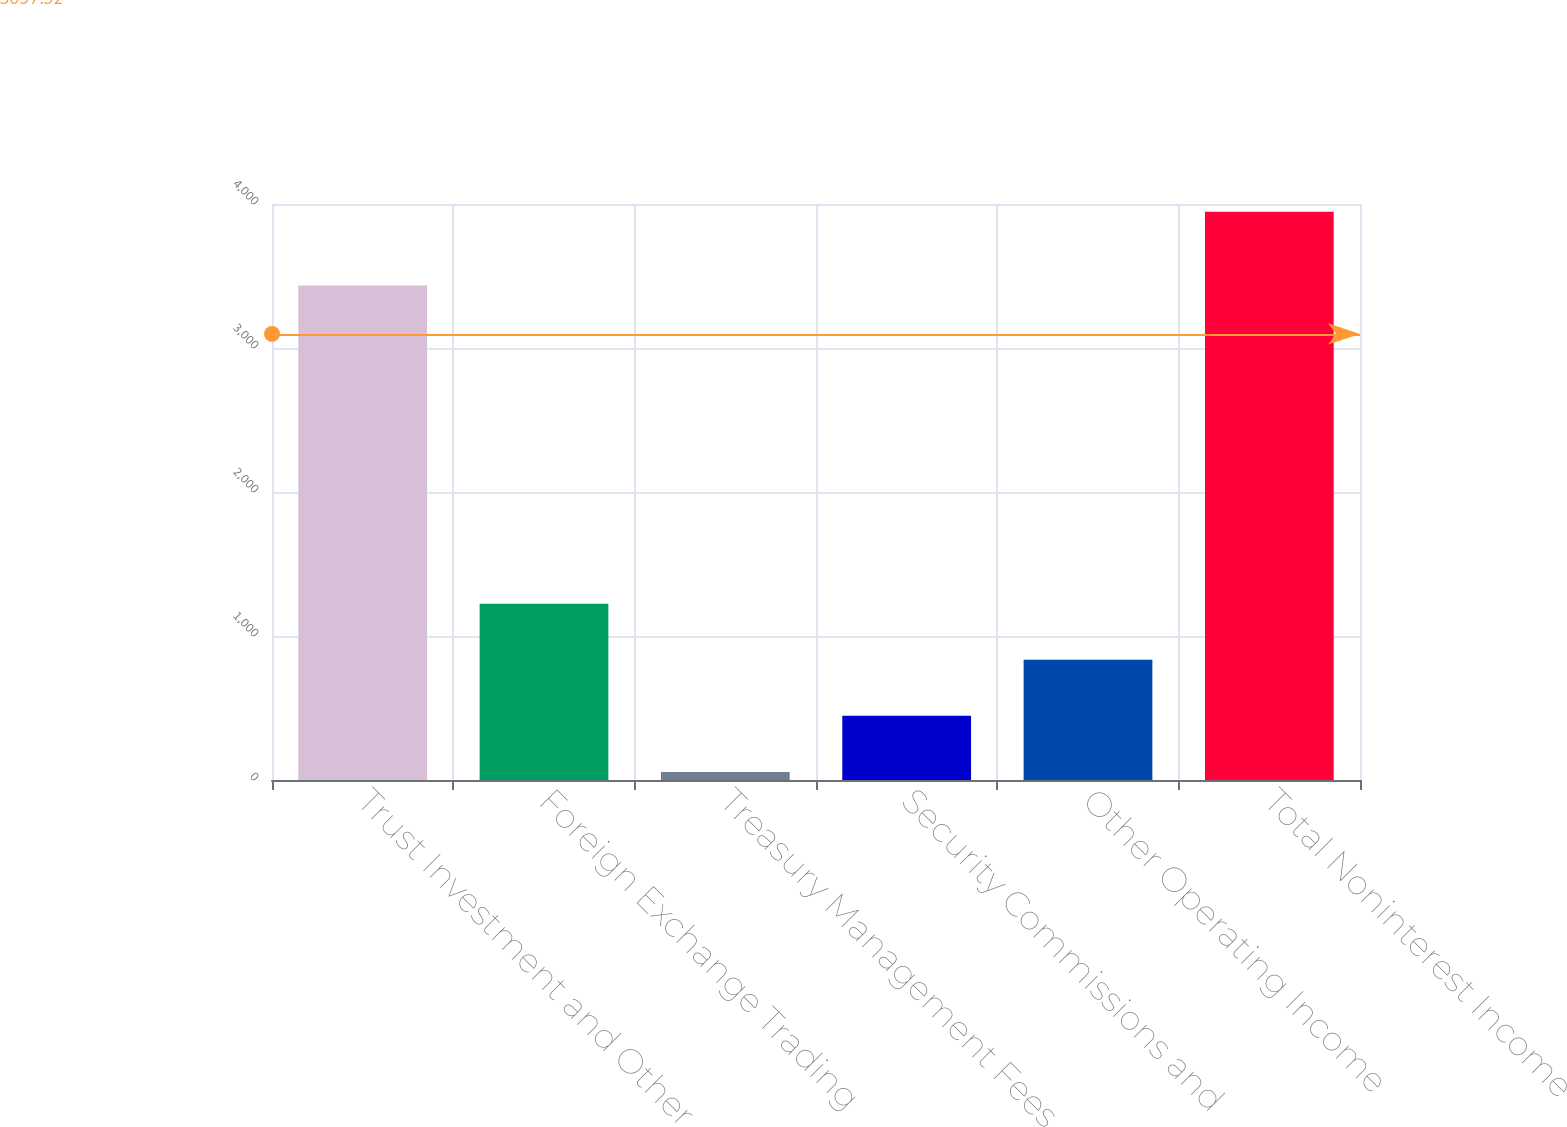Convert chart to OTSL. <chart><loc_0><loc_0><loc_500><loc_500><bar_chart><fcel>Trust Investment and Other<fcel>Foreign Exchange Trading<fcel>Treasury Management Fees<fcel>Security Commissions and<fcel>Other Operating Income<fcel>Total Noninterest Income<nl><fcel>3434.3<fcel>1223.31<fcel>56.4<fcel>445.37<fcel>834.34<fcel>3946.1<nl></chart> 